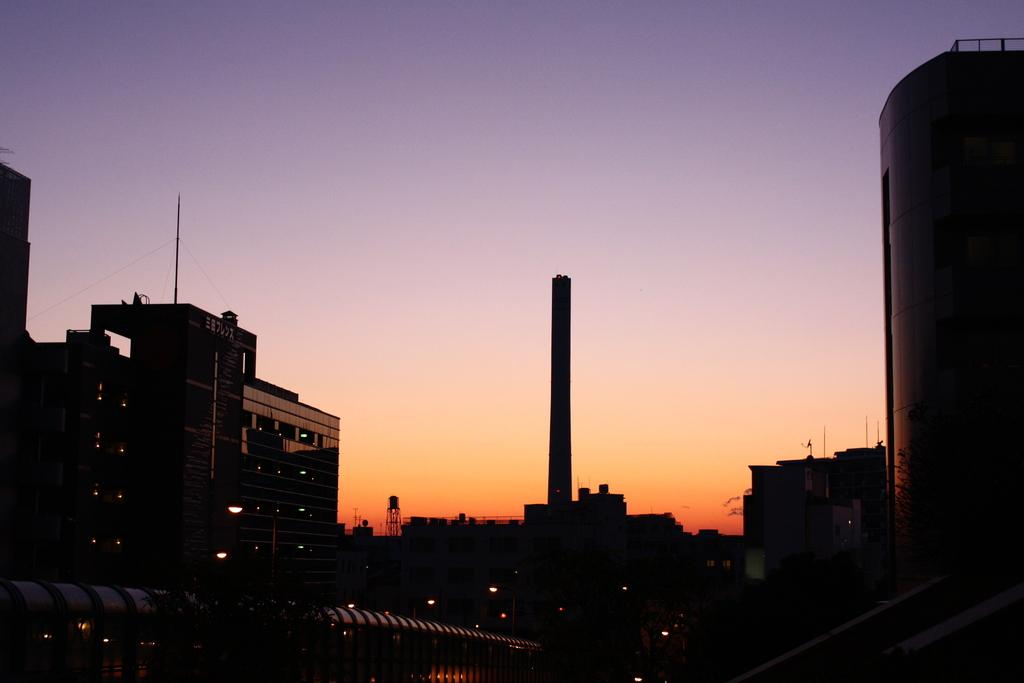What type of structures are present in the image? There are buildings in the image. What is visible at the top of the image? The sky is visible at the top of the image. What can be seen in the middle of the image? There is a tower in the middle of the image. What type of reward is hanging from the tower in the image? There is no reward present in the image; it features buildings, the sky, and a tower. Can you see any ears on the buildings in the image? There are no ears present on the buildings in the image. 